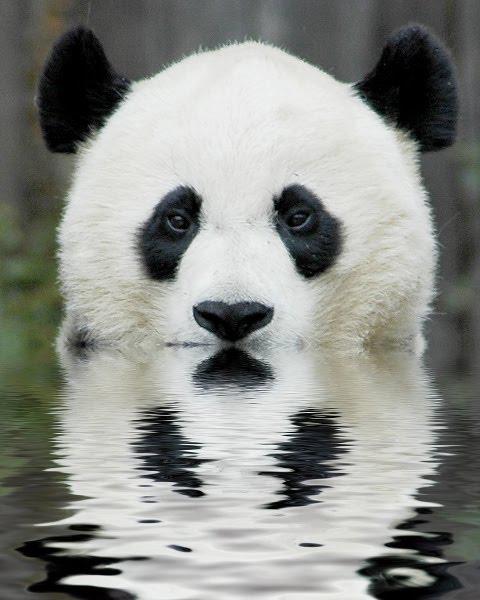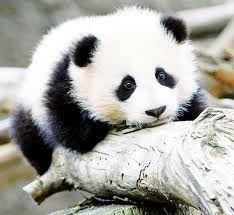The first image is the image on the left, the second image is the image on the right. Assess this claim about the two images: "At least one image shows a panda in water near a rock formation.". Correct or not? Answer yes or no. No. The first image is the image on the left, the second image is the image on the right. Examine the images to the left and right. Is the description "One panda is in calm water." accurate? Answer yes or no. Yes. 